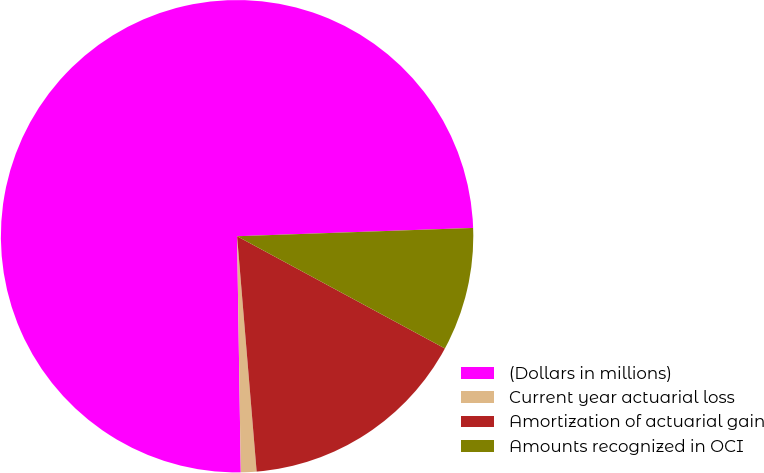Convert chart. <chart><loc_0><loc_0><loc_500><loc_500><pie_chart><fcel>(Dollars in millions)<fcel>Current year actuarial loss<fcel>Amortization of actuarial gain<fcel>Amounts recognized in OCI<nl><fcel>74.69%<fcel>1.07%<fcel>15.8%<fcel>8.44%<nl></chart> 